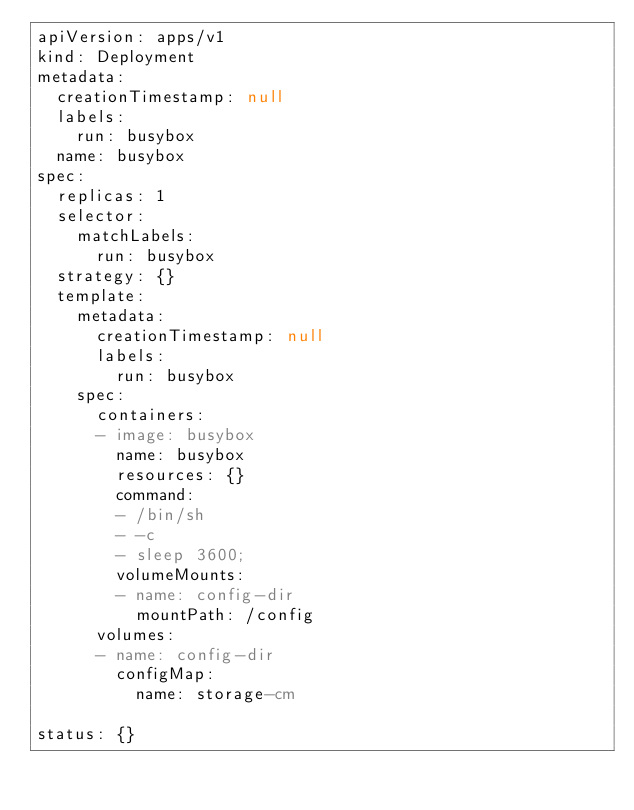Convert code to text. <code><loc_0><loc_0><loc_500><loc_500><_YAML_>apiVersion: apps/v1
kind: Deployment
metadata:
  creationTimestamp: null
  labels:
    run: busybox
  name: busybox
spec:
  replicas: 1
  selector:
    matchLabels:
      run: busybox
  strategy: {}
  template:
    metadata:
      creationTimestamp: null
      labels:
        run: busybox
    spec:
      containers:
      - image: busybox
        name: busybox
        resources: {}
        command:
        - /bin/sh
        - -c 
        - sleep 3600;
        volumeMounts:
        - name: config-dir
          mountPath: /config
      volumes:
      - name: config-dir
        configMap:
          name: storage-cm
        
status: {}
</code> 